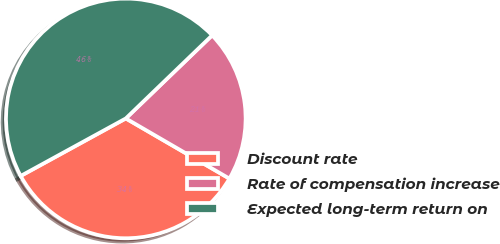Convert chart to OTSL. <chart><loc_0><loc_0><loc_500><loc_500><pie_chart><fcel>Discount rate<fcel>Rate of compensation increase<fcel>Expected long-term return on<nl><fcel>33.66%<fcel>20.57%<fcel>45.77%<nl></chart> 